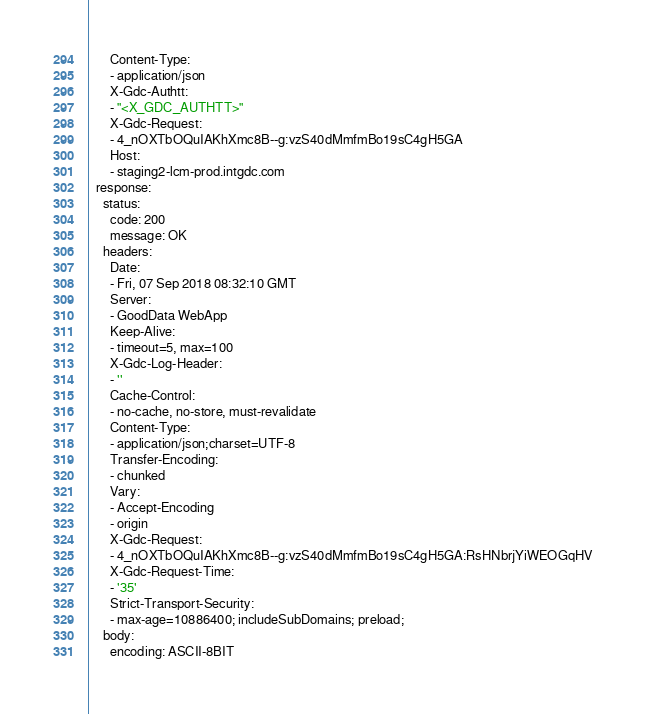Convert code to text. <code><loc_0><loc_0><loc_500><loc_500><_YAML_>      Content-Type:
      - application/json
      X-Gdc-Authtt:
      - "<X_GDC_AUTHTT>"
      X-Gdc-Request:
      - 4_nOXTbOQuIAKhXmc8B--g:vzS40dMmfmBo19sC4gH5GA
      Host:
      - staging2-lcm-prod.intgdc.com
  response:
    status:
      code: 200
      message: OK
    headers:
      Date:
      - Fri, 07 Sep 2018 08:32:10 GMT
      Server:
      - GoodData WebApp
      Keep-Alive:
      - timeout=5, max=100
      X-Gdc-Log-Header:
      - ''
      Cache-Control:
      - no-cache, no-store, must-revalidate
      Content-Type:
      - application/json;charset=UTF-8
      Transfer-Encoding:
      - chunked
      Vary:
      - Accept-Encoding
      - origin
      X-Gdc-Request:
      - 4_nOXTbOQuIAKhXmc8B--g:vzS40dMmfmBo19sC4gH5GA:RsHNbrjYiWEOGqHV
      X-Gdc-Request-Time:
      - '35'
      Strict-Transport-Security:
      - max-age=10886400; includeSubDomains; preload;
    body:
      encoding: ASCII-8BIT</code> 